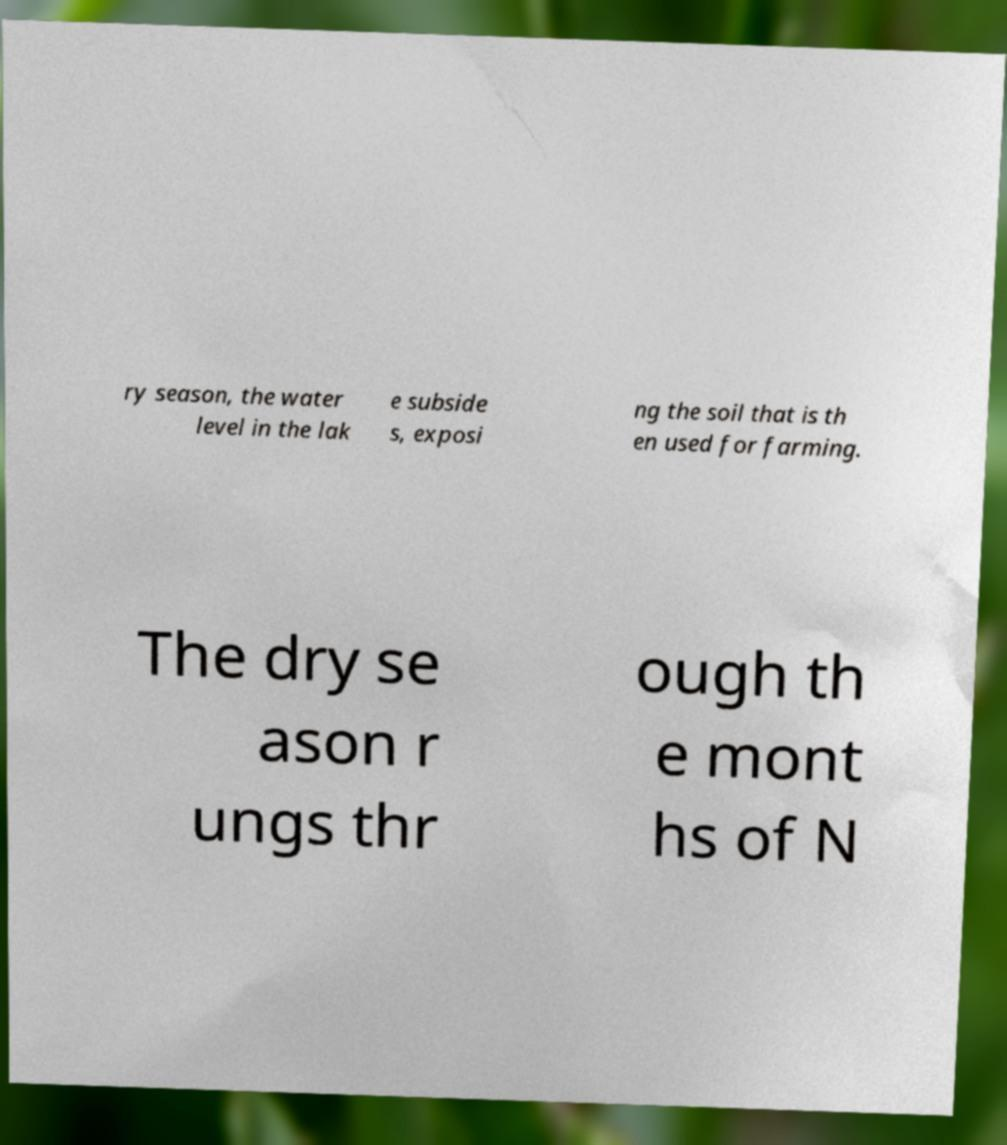I need the written content from this picture converted into text. Can you do that? ry season, the water level in the lak e subside s, exposi ng the soil that is th en used for farming. The dry se ason r ungs thr ough th e mont hs of N 